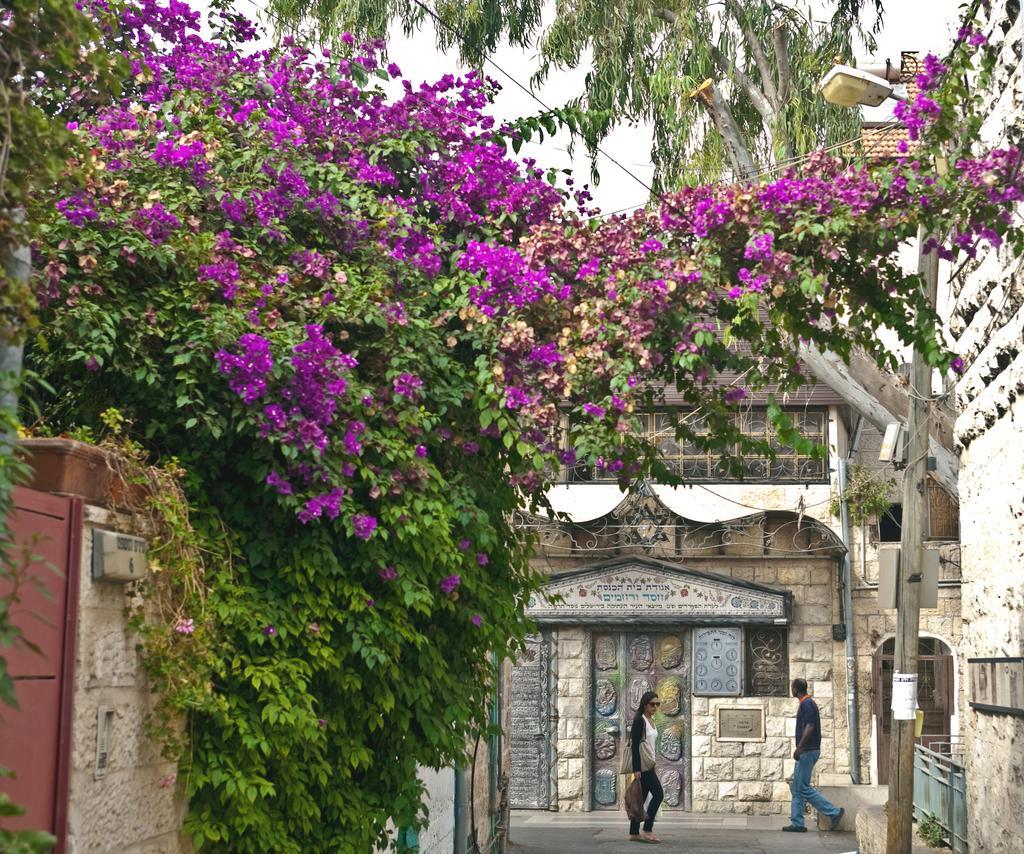How would you summarize this image in a sentence or two? In this picture we can see a man and a woman walking on the road, trees, pole, light, buildings with windows and in the background we can see sky. 